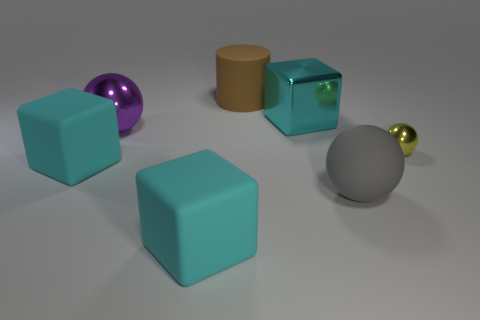Is there anything else that has the same shape as the brown rubber object?
Offer a very short reply. No. Is there anything else that has the same size as the yellow metallic object?
Offer a terse response. No. Is there a cyan matte object of the same shape as the gray matte object?
Make the answer very short. No. Is the color of the big matte thing that is in front of the big rubber sphere the same as the small shiny object?
Offer a terse response. No. Is the size of the shiny sphere that is left of the yellow metallic sphere the same as the sphere that is in front of the small yellow thing?
Your response must be concise. Yes. What size is the sphere that is made of the same material as the large brown object?
Your answer should be very brief. Large. How many objects are to the left of the brown rubber cylinder and behind the small metal object?
Make the answer very short. 1. How many objects are rubber blocks or large cyan rubber blocks in front of the big gray matte ball?
Provide a short and direct response. 2. What is the color of the big sphere in front of the yellow object?
Offer a very short reply. Gray. How many things are either cyan rubber blocks to the left of the purple sphere or tiny red metal things?
Give a very brief answer. 1. 